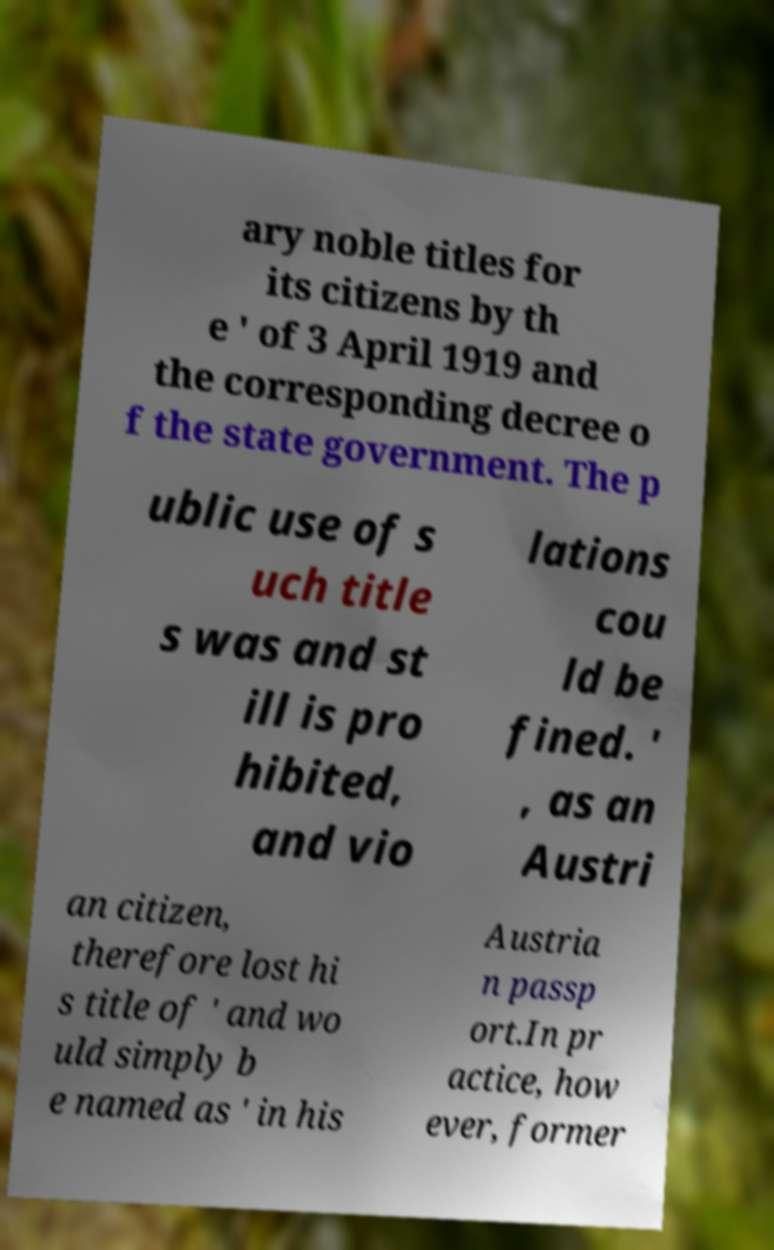Please identify and transcribe the text found in this image. ary noble titles for its citizens by th e ' of 3 April 1919 and the corresponding decree o f the state government. The p ublic use of s uch title s was and st ill is pro hibited, and vio lations cou ld be fined. ' , as an Austri an citizen, therefore lost hi s title of ' and wo uld simply b e named as ' in his Austria n passp ort.In pr actice, how ever, former 